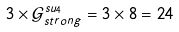Convert formula to latex. <formula><loc_0><loc_0><loc_500><loc_500>3 \times \mathcal { G } _ { s t r o n g } ^ { s u _ { 4 } } = 3 \times 8 = 2 4</formula> 